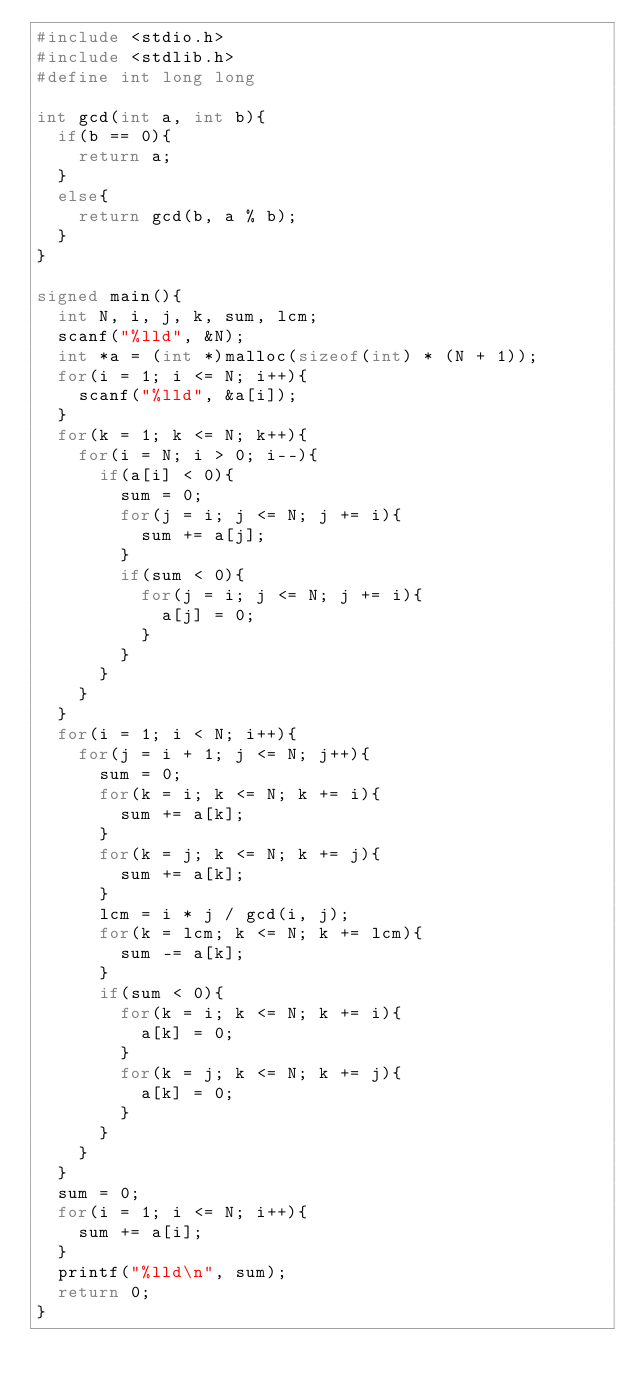<code> <loc_0><loc_0><loc_500><loc_500><_C_>#include <stdio.h>
#include <stdlib.h>
#define int long long

int gcd(int a, int b){
	if(b == 0){
		return a;
	}
	else{
		return gcd(b, a % b);
	}
}

signed main(){
	int N, i, j, k, sum, lcm;
	scanf("%lld", &N);
	int *a = (int *)malloc(sizeof(int) * (N + 1));
	for(i = 1; i <= N; i++){
		scanf("%lld", &a[i]);
	}
	for(k = 1; k <= N; k++){
		for(i = N; i > 0; i--){
			if(a[i] < 0){
				sum = 0;
				for(j = i; j <= N; j += i){
					sum += a[j];
				}
				if(sum < 0){
					for(j = i; j <= N; j += i){
						a[j] = 0;
					}
				}
			}
		}
	}
	for(i = 1; i < N; i++){
		for(j = i + 1; j <= N; j++){
			sum = 0;
			for(k = i; k <= N; k += i){
				sum += a[k];
			}
			for(k = j; k <= N; k += j){
				sum += a[k];
			}
			lcm = i * j / gcd(i, j);
			for(k = lcm; k <= N; k += lcm){
				sum -= a[k];
			}
			if(sum < 0){
				for(k = i; k <= N; k += i){
					a[k] = 0;
				}
				for(k = j; k <= N; k += j){
					a[k] = 0;
				}
			}
		}
	}
	sum = 0;
	for(i = 1; i <= N; i++){
		sum += a[i];
	}
	printf("%lld\n", sum);
	return 0;
}</code> 